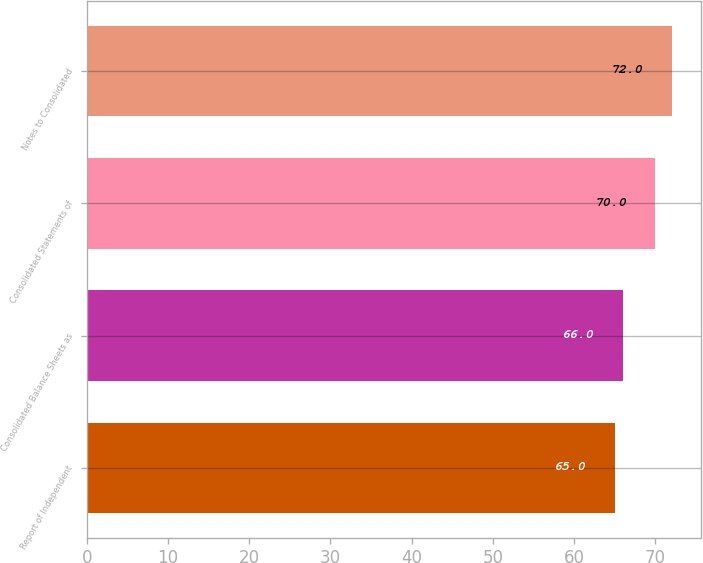Convert chart to OTSL. <chart><loc_0><loc_0><loc_500><loc_500><bar_chart><fcel>Report of Independent<fcel>Consolidated Balance Sheets as<fcel>Consolidated Statements of<fcel>Notes to Consolidated<nl><fcel>65<fcel>66<fcel>70<fcel>72<nl></chart> 